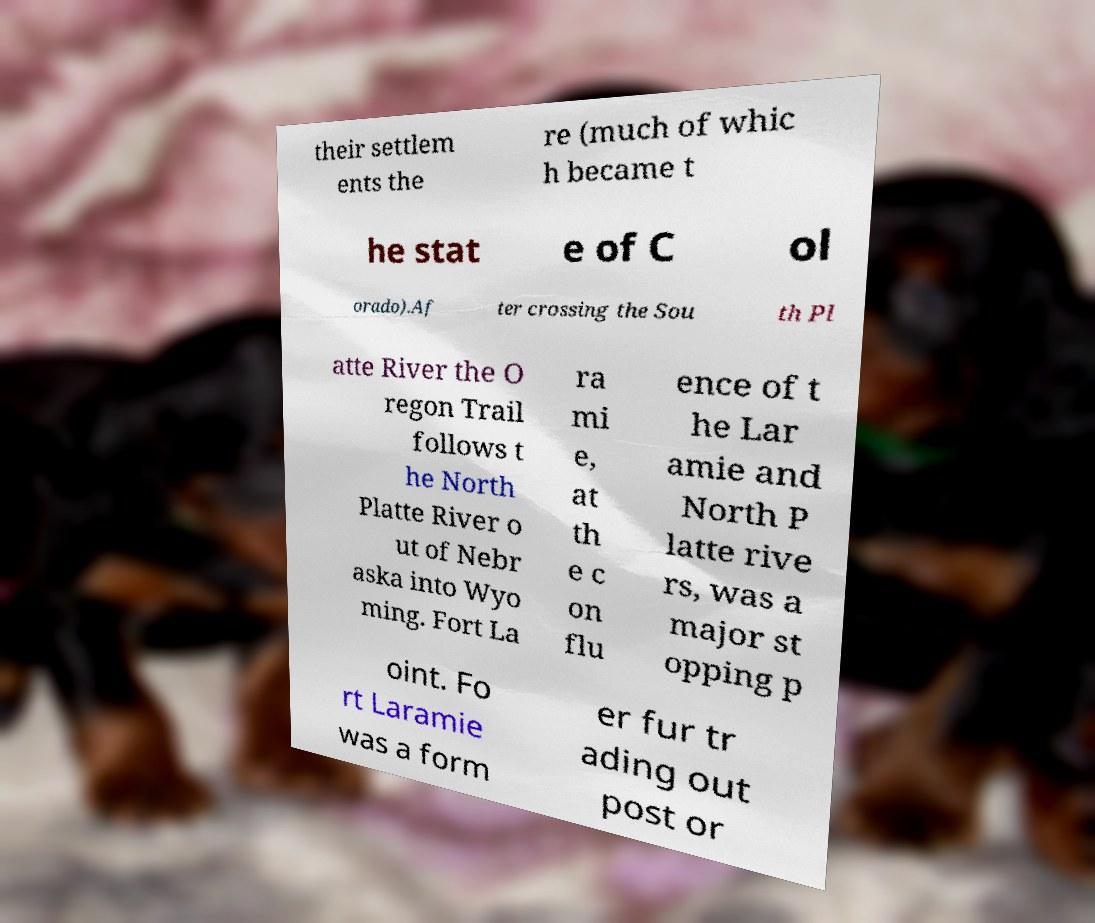Please identify and transcribe the text found in this image. their settlem ents the re (much of whic h became t he stat e of C ol orado).Af ter crossing the Sou th Pl atte River the O regon Trail follows t he North Platte River o ut of Nebr aska into Wyo ming. Fort La ra mi e, at th e c on flu ence of t he Lar amie and North P latte rive rs, was a major st opping p oint. Fo rt Laramie was a form er fur tr ading out post or 